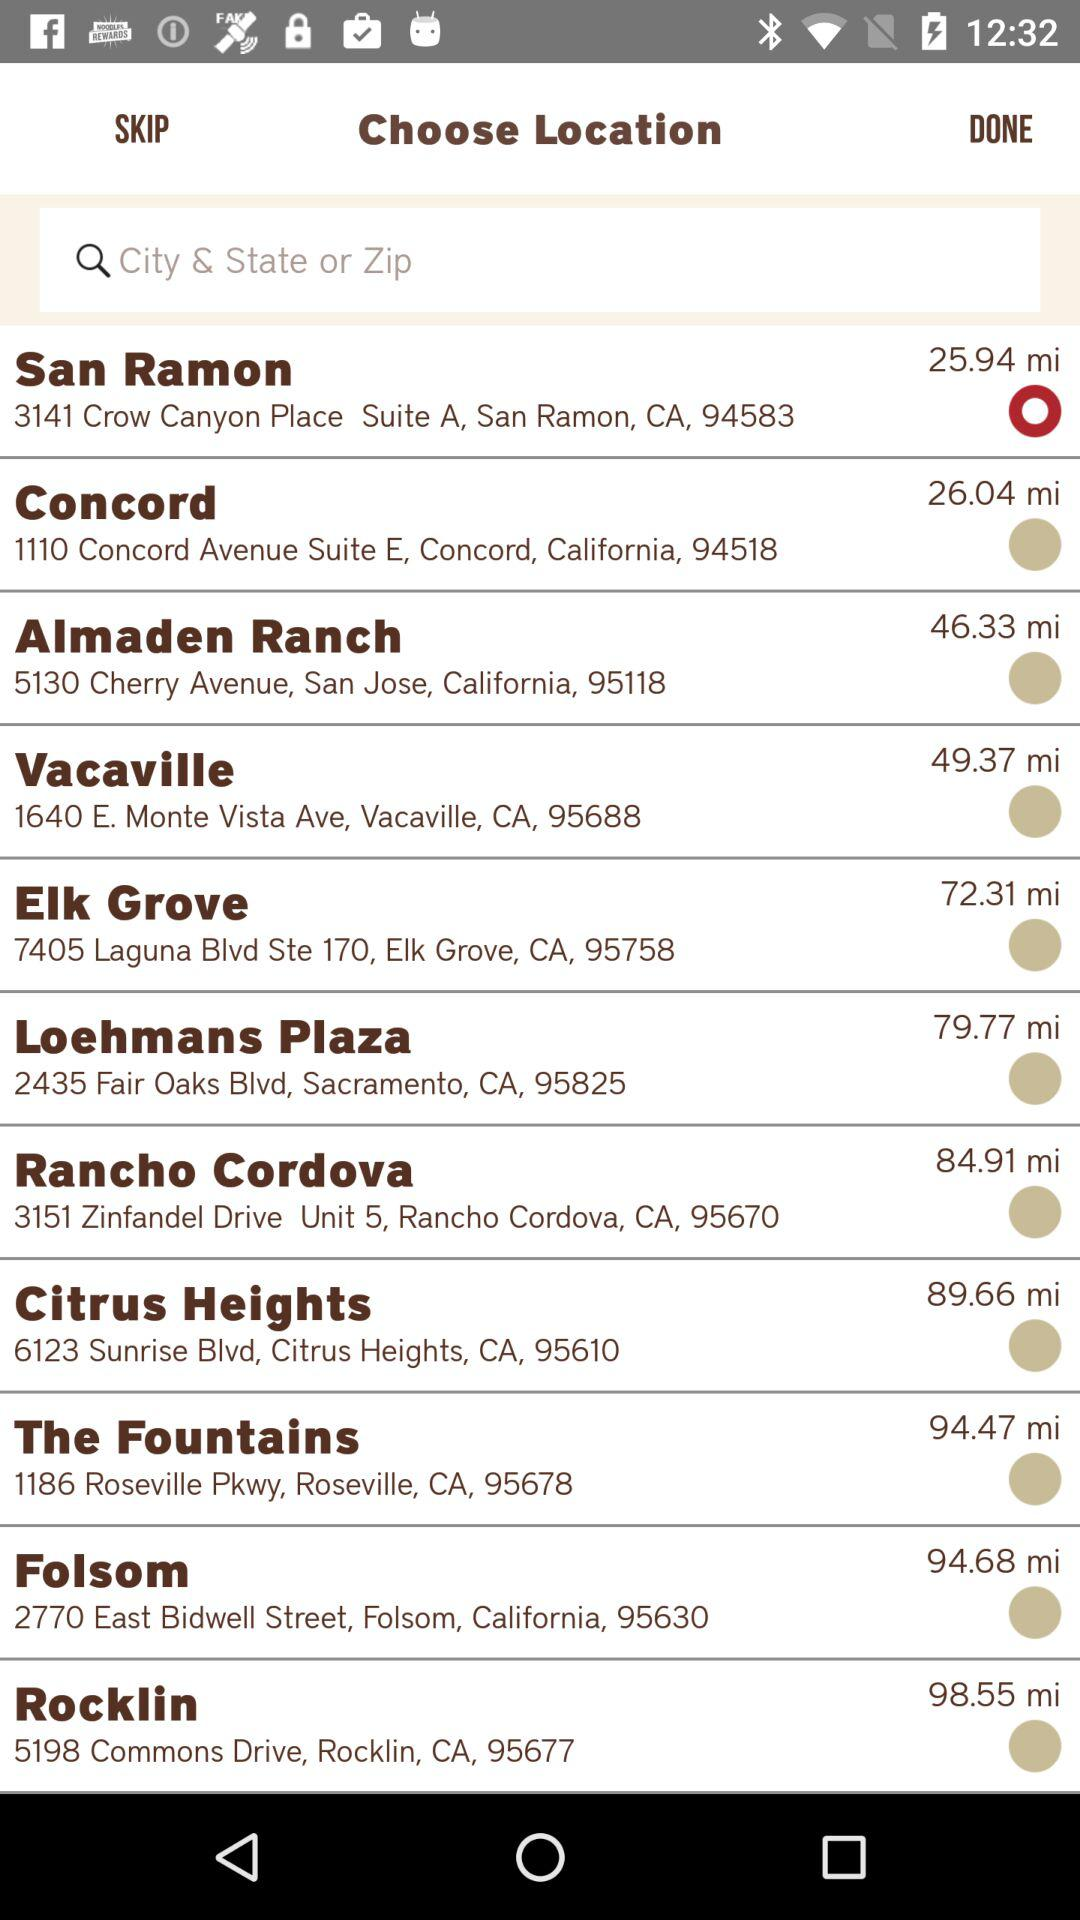Which is the selected location? The selected location is 3141 Crow Canyon Place, Suite A, San Ramon, CA, 94583. 